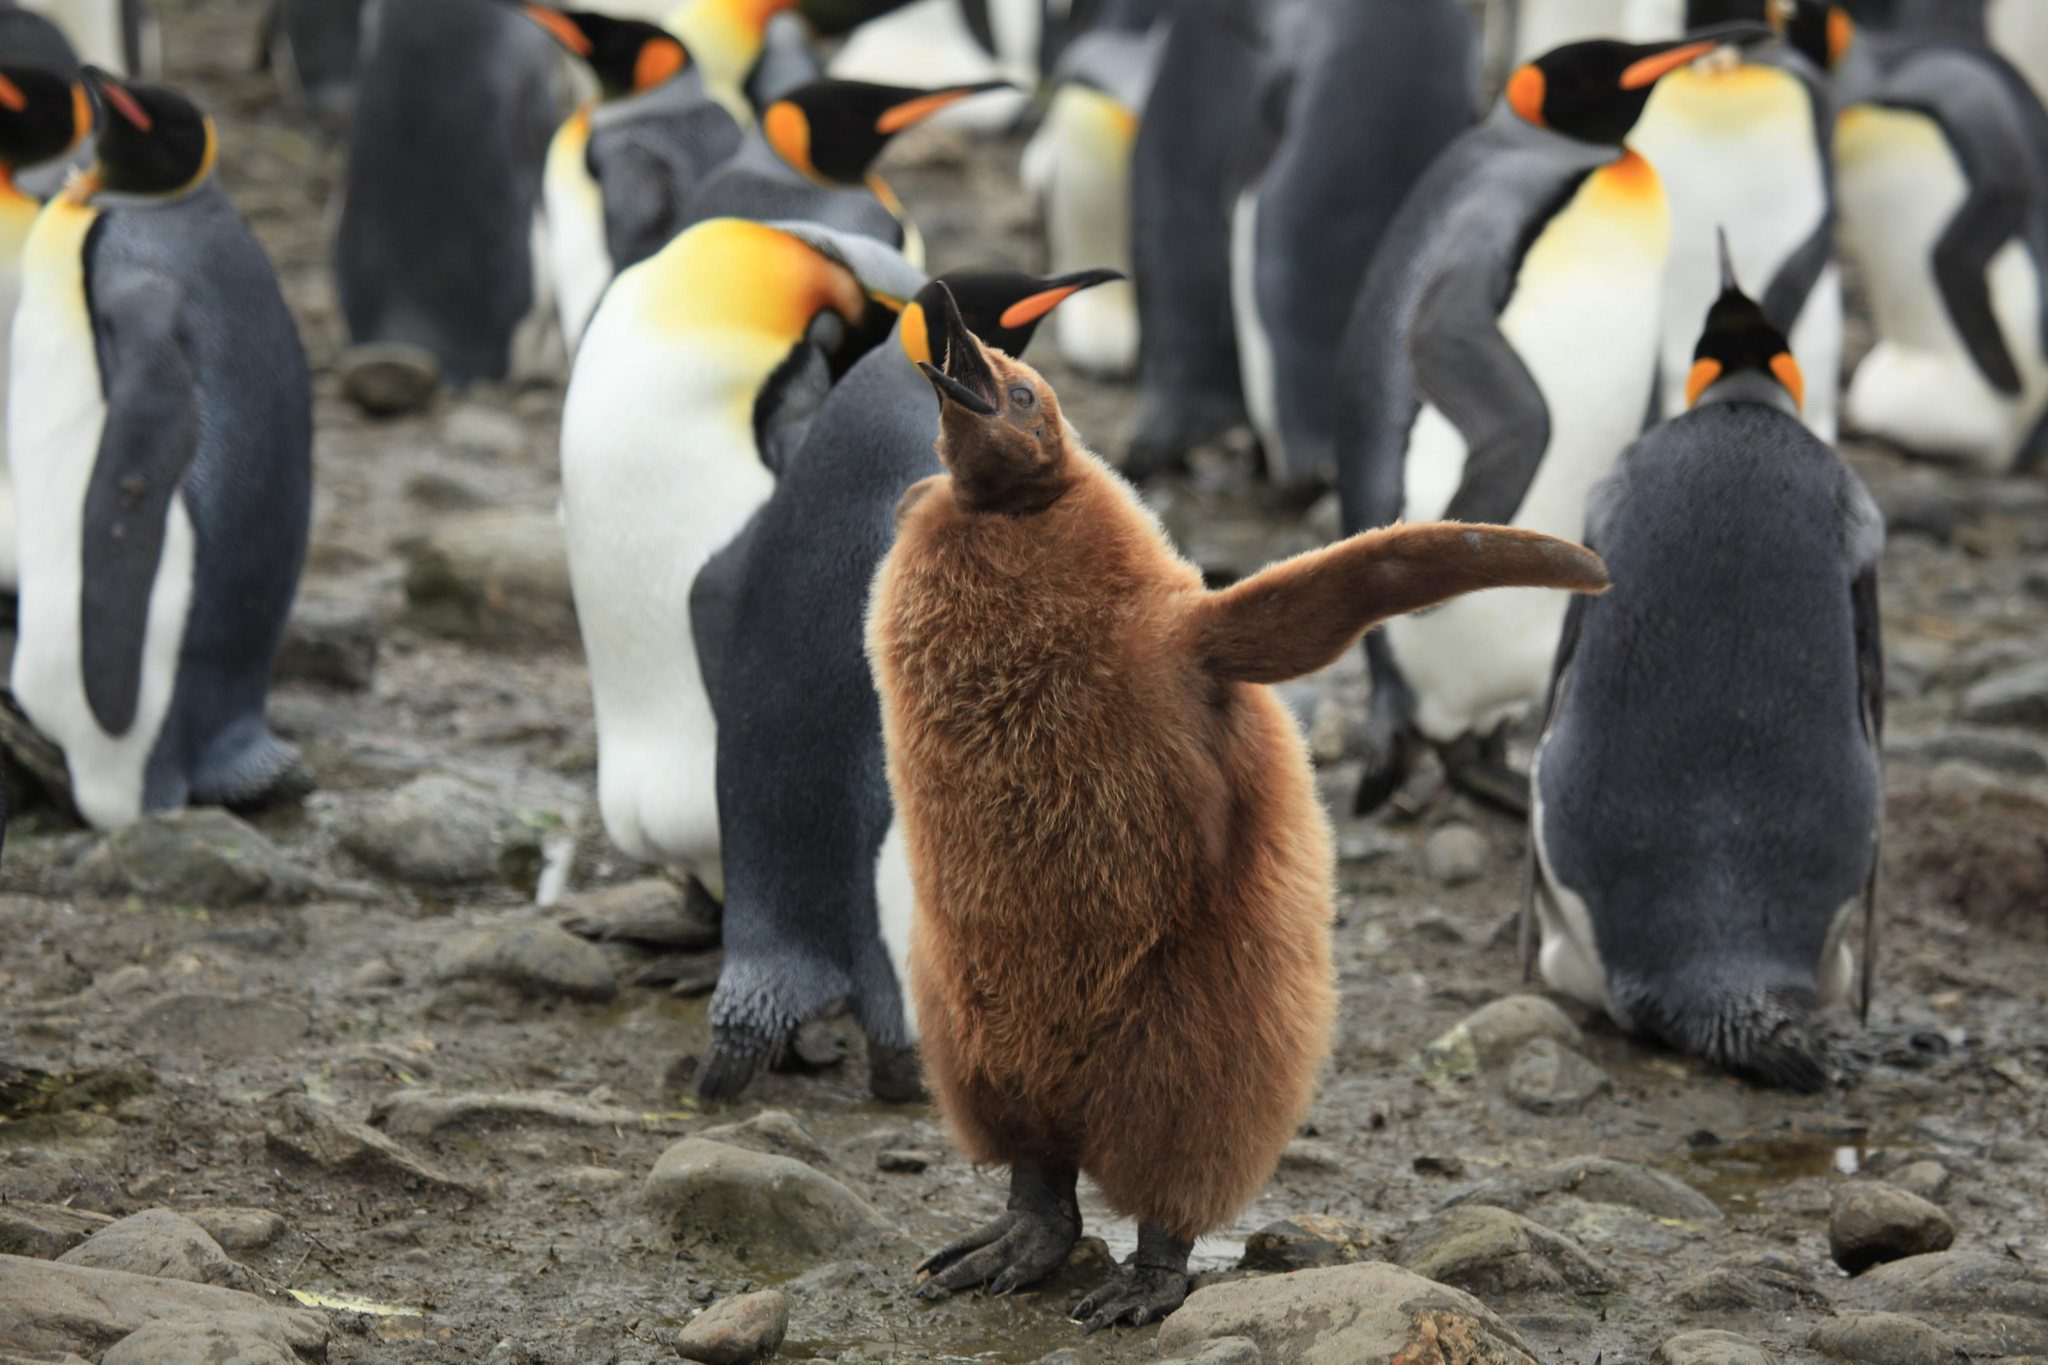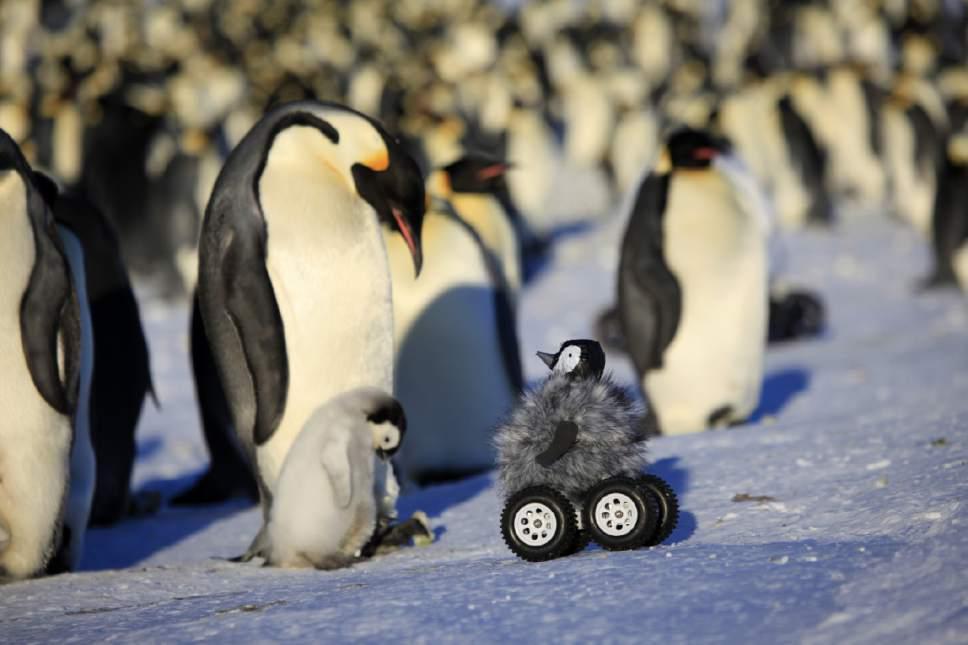The first image is the image on the left, the second image is the image on the right. Assess this claim about the two images: "There are penguins standing on snow.". Correct or not? Answer yes or no. No. The first image is the image on the left, the second image is the image on the right. Evaluate the accuracy of this statement regarding the images: "In one image, the foreground includes at least one penguin fully covered in fuzzy brown.". Is it true? Answer yes or no. Yes. 